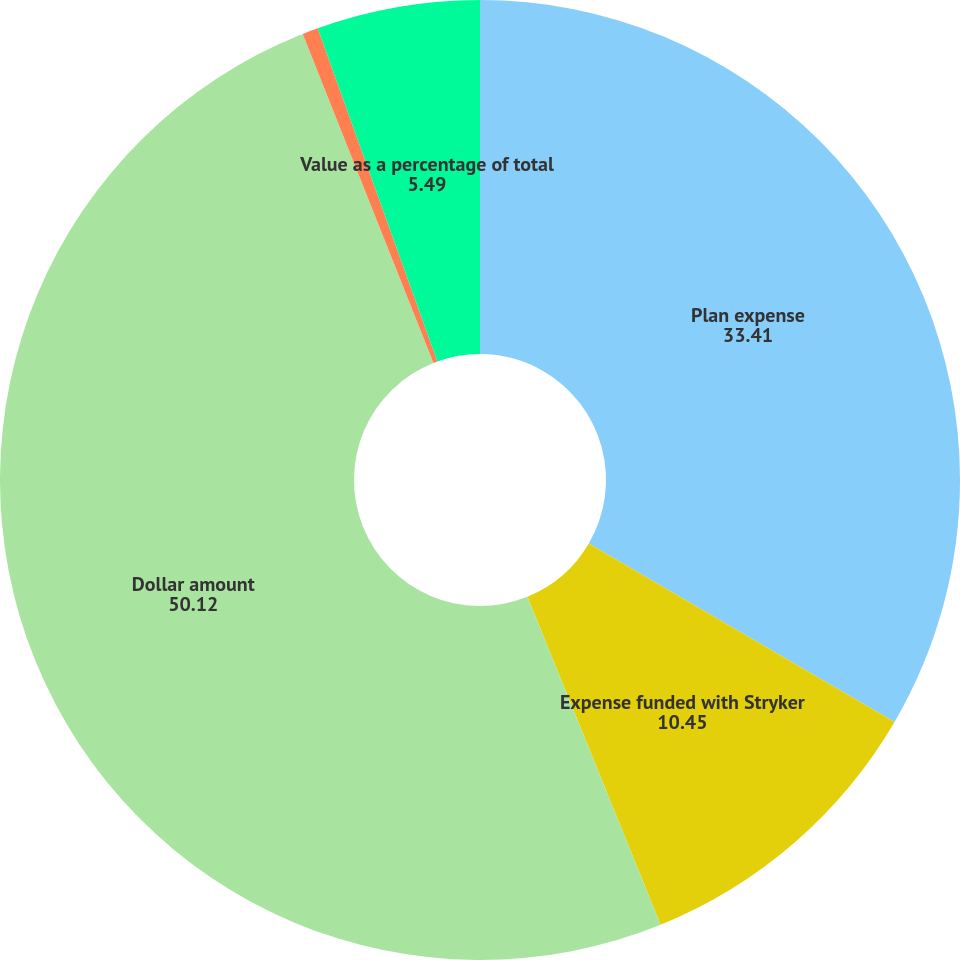<chart> <loc_0><loc_0><loc_500><loc_500><pie_chart><fcel>Plan expense<fcel>Expense funded with Stryker<fcel>Dollar amount<fcel>Shares (in millions of shares)<fcel>Value as a percentage of total<nl><fcel>33.41%<fcel>10.45%<fcel>50.12%<fcel>0.53%<fcel>5.49%<nl></chart> 